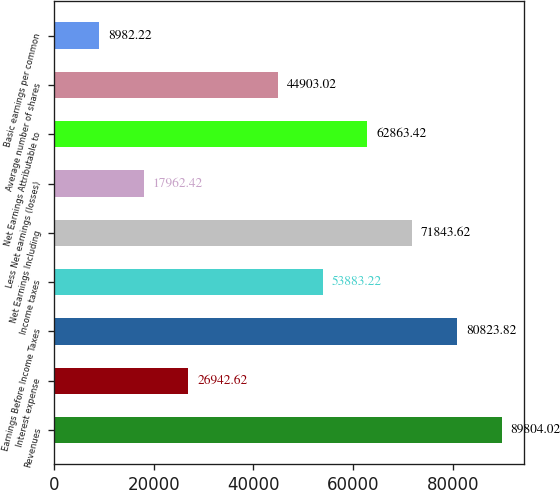Convert chart. <chart><loc_0><loc_0><loc_500><loc_500><bar_chart><fcel>Revenues<fcel>Interest expense<fcel>Earnings Before Income Taxes<fcel>Income taxes<fcel>Net Earnings Including<fcel>Less Net earnings (losses)<fcel>Net Earnings Attributable to<fcel>Average number of shares<fcel>Basic earnings per common<nl><fcel>89804<fcel>26942.6<fcel>80823.8<fcel>53883.2<fcel>71843.6<fcel>17962.4<fcel>62863.4<fcel>44903<fcel>8982.22<nl></chart> 